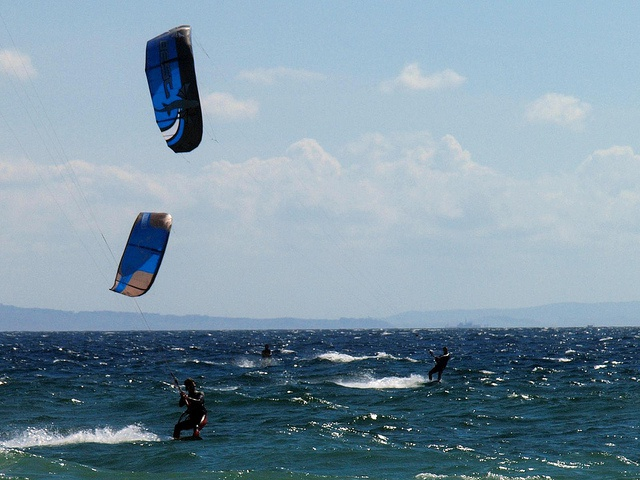Describe the objects in this image and their specific colors. I can see kite in lightblue, black, navy, blue, and darkgray tones, kite in lightblue, navy, black, gray, and blue tones, people in lightblue, black, gray, maroon, and darkblue tones, people in lightblue, black, navy, blue, and gray tones, and people in lightblue, black, navy, gray, and darkblue tones in this image. 